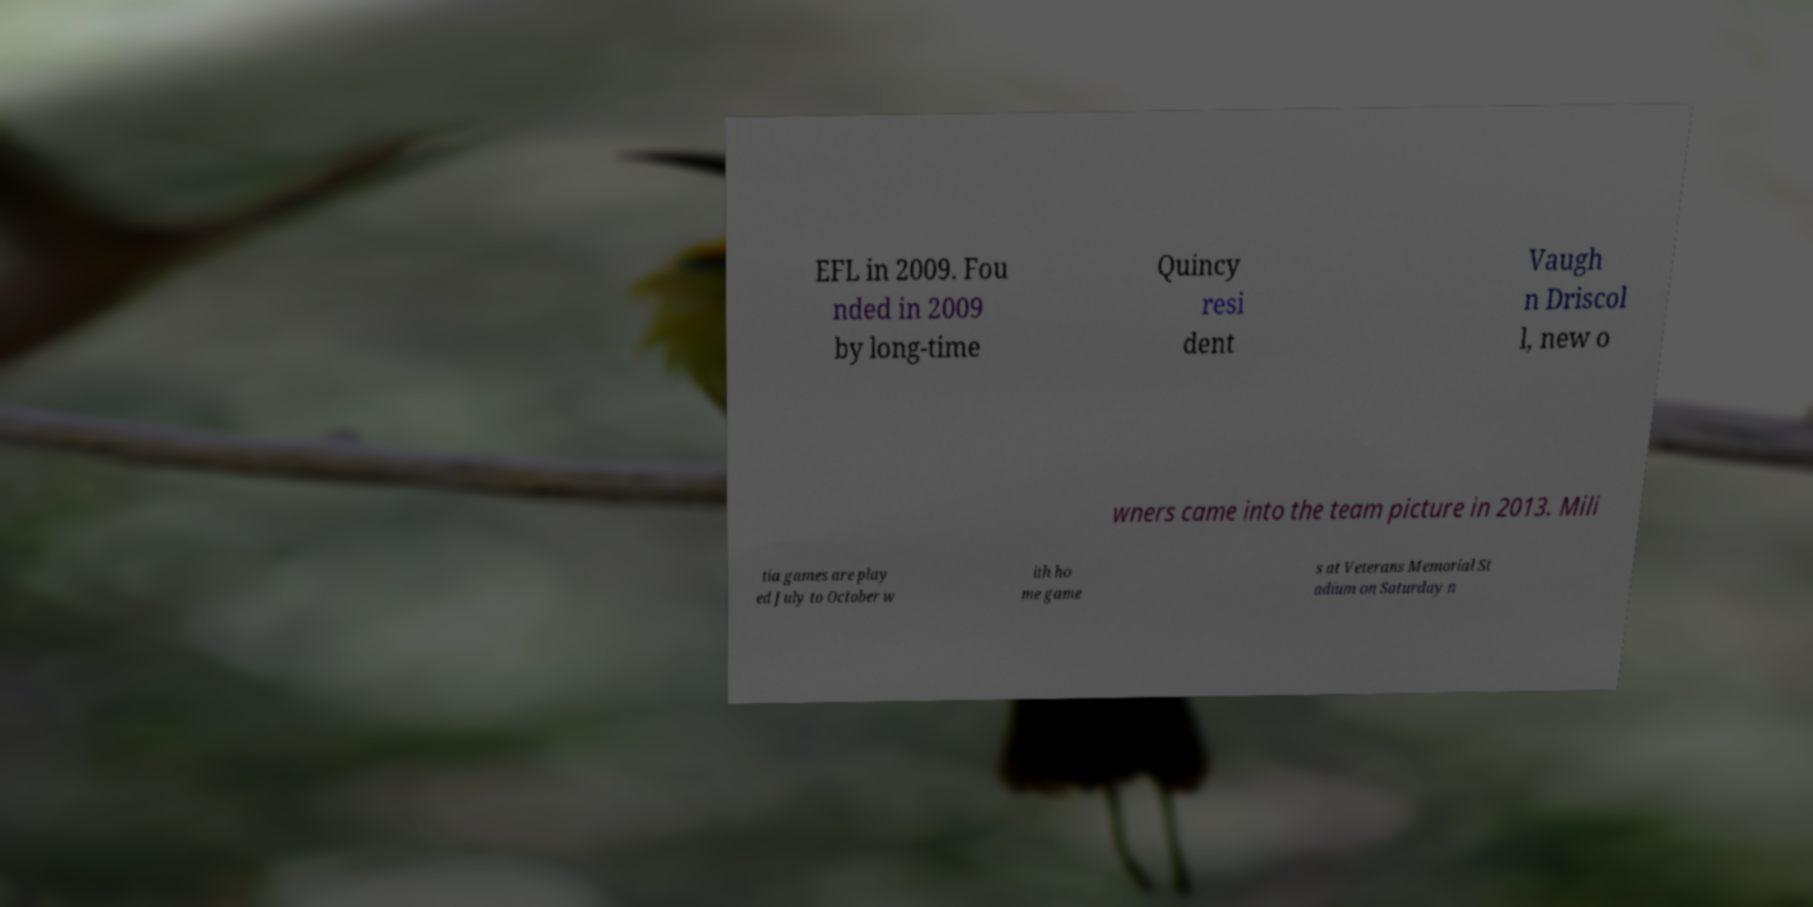Could you assist in decoding the text presented in this image and type it out clearly? EFL in 2009. Fou nded in 2009 by long-time Quincy resi dent Vaugh n Driscol l, new o wners came into the team picture in 2013. Mili tia games are play ed July to October w ith ho me game s at Veterans Memorial St adium on Saturday n 